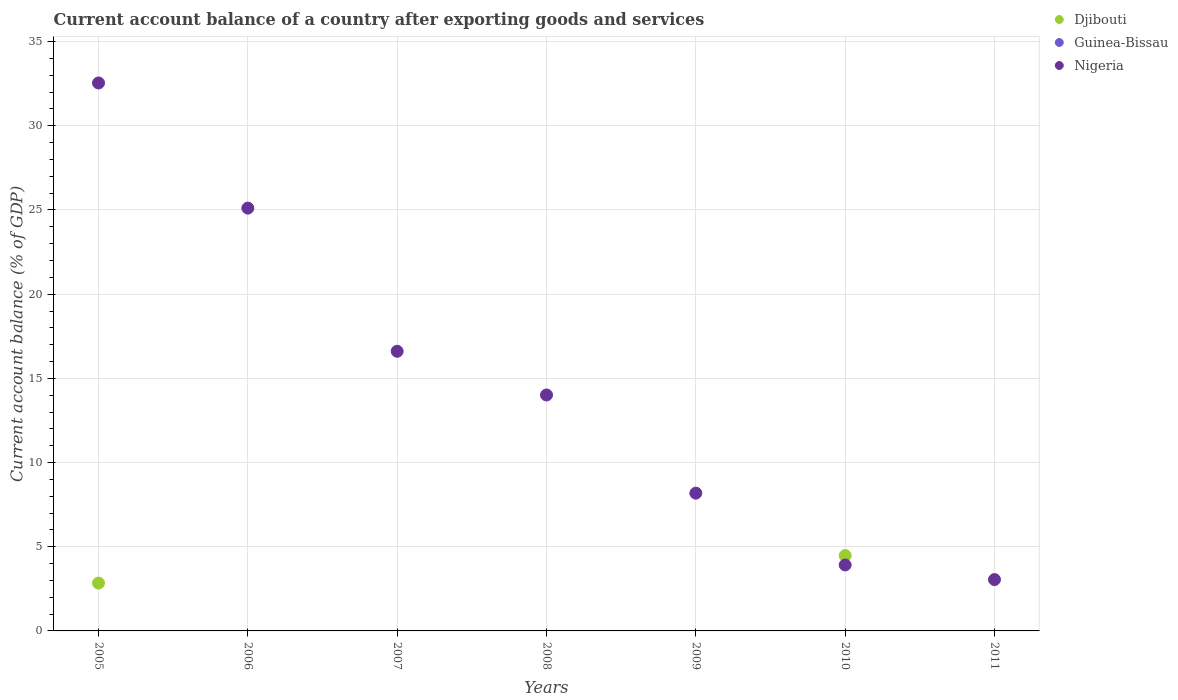Is the number of dotlines equal to the number of legend labels?
Offer a terse response. No. Across all years, what is the maximum account balance in Nigeria?
Keep it short and to the point. 32.54. Across all years, what is the minimum account balance in Nigeria?
Your response must be concise. 3.05. What is the total account balance in Nigeria in the graph?
Provide a short and direct response. 103.42. What is the difference between the account balance in Djibouti in 2005 and that in 2010?
Provide a short and direct response. -1.63. What is the difference between the account balance in Guinea-Bissau in 2007 and the account balance in Nigeria in 2010?
Give a very brief answer. -3.92. What is the average account balance in Djibouti per year?
Provide a succinct answer. 1.04. In how many years, is the account balance in Nigeria greater than 29 %?
Give a very brief answer. 1. What is the ratio of the account balance in Nigeria in 2005 to that in 2009?
Ensure brevity in your answer.  3.98. What is the difference between the highest and the second highest account balance in Nigeria?
Your answer should be compact. 7.43. What is the difference between the highest and the lowest account balance in Nigeria?
Your answer should be compact. 29.49. Is it the case that in every year, the sum of the account balance in Nigeria and account balance in Guinea-Bissau  is greater than the account balance in Djibouti?
Make the answer very short. No. How many dotlines are there?
Your response must be concise. 2. How many years are there in the graph?
Give a very brief answer. 7. Where does the legend appear in the graph?
Your answer should be very brief. Top right. How are the legend labels stacked?
Ensure brevity in your answer.  Vertical. What is the title of the graph?
Give a very brief answer. Current account balance of a country after exporting goods and services. Does "Egypt, Arab Rep." appear as one of the legend labels in the graph?
Provide a short and direct response. No. What is the label or title of the Y-axis?
Make the answer very short. Current account balance (% of GDP). What is the Current account balance (% of GDP) of Djibouti in 2005?
Your response must be concise. 2.84. What is the Current account balance (% of GDP) of Nigeria in 2005?
Give a very brief answer. 32.54. What is the Current account balance (% of GDP) in Djibouti in 2006?
Your answer should be very brief. 0. What is the Current account balance (% of GDP) of Nigeria in 2006?
Provide a short and direct response. 25.11. What is the Current account balance (% of GDP) in Nigeria in 2007?
Offer a very short reply. 16.61. What is the Current account balance (% of GDP) of Guinea-Bissau in 2008?
Make the answer very short. 0. What is the Current account balance (% of GDP) in Nigeria in 2008?
Provide a short and direct response. 14.01. What is the Current account balance (% of GDP) in Djibouti in 2009?
Your answer should be compact. 0. What is the Current account balance (% of GDP) in Nigeria in 2009?
Keep it short and to the point. 8.18. What is the Current account balance (% of GDP) in Djibouti in 2010?
Your answer should be very brief. 4.47. What is the Current account balance (% of GDP) of Nigeria in 2010?
Offer a very short reply. 3.92. What is the Current account balance (% of GDP) of Nigeria in 2011?
Make the answer very short. 3.05. Across all years, what is the maximum Current account balance (% of GDP) in Djibouti?
Your answer should be compact. 4.47. Across all years, what is the maximum Current account balance (% of GDP) in Nigeria?
Make the answer very short. 32.54. Across all years, what is the minimum Current account balance (% of GDP) in Nigeria?
Make the answer very short. 3.05. What is the total Current account balance (% of GDP) of Djibouti in the graph?
Make the answer very short. 7.31. What is the total Current account balance (% of GDP) in Nigeria in the graph?
Give a very brief answer. 103.42. What is the difference between the Current account balance (% of GDP) of Nigeria in 2005 and that in 2006?
Give a very brief answer. 7.43. What is the difference between the Current account balance (% of GDP) of Nigeria in 2005 and that in 2007?
Your answer should be compact. 15.94. What is the difference between the Current account balance (% of GDP) of Nigeria in 2005 and that in 2008?
Ensure brevity in your answer.  18.53. What is the difference between the Current account balance (% of GDP) of Nigeria in 2005 and that in 2009?
Offer a terse response. 24.36. What is the difference between the Current account balance (% of GDP) of Djibouti in 2005 and that in 2010?
Your answer should be compact. -1.63. What is the difference between the Current account balance (% of GDP) in Nigeria in 2005 and that in 2010?
Your answer should be very brief. 28.63. What is the difference between the Current account balance (% of GDP) of Nigeria in 2005 and that in 2011?
Provide a succinct answer. 29.49. What is the difference between the Current account balance (% of GDP) in Nigeria in 2006 and that in 2007?
Ensure brevity in your answer.  8.5. What is the difference between the Current account balance (% of GDP) of Nigeria in 2006 and that in 2008?
Your answer should be very brief. 11.1. What is the difference between the Current account balance (% of GDP) in Nigeria in 2006 and that in 2009?
Offer a terse response. 16.93. What is the difference between the Current account balance (% of GDP) in Nigeria in 2006 and that in 2010?
Provide a succinct answer. 21.19. What is the difference between the Current account balance (% of GDP) in Nigeria in 2006 and that in 2011?
Provide a short and direct response. 22.06. What is the difference between the Current account balance (% of GDP) of Nigeria in 2007 and that in 2008?
Ensure brevity in your answer.  2.6. What is the difference between the Current account balance (% of GDP) in Nigeria in 2007 and that in 2009?
Provide a short and direct response. 8.43. What is the difference between the Current account balance (% of GDP) of Nigeria in 2007 and that in 2010?
Make the answer very short. 12.69. What is the difference between the Current account balance (% of GDP) of Nigeria in 2007 and that in 2011?
Provide a short and direct response. 13.56. What is the difference between the Current account balance (% of GDP) in Nigeria in 2008 and that in 2009?
Ensure brevity in your answer.  5.83. What is the difference between the Current account balance (% of GDP) in Nigeria in 2008 and that in 2010?
Keep it short and to the point. 10.09. What is the difference between the Current account balance (% of GDP) in Nigeria in 2008 and that in 2011?
Ensure brevity in your answer.  10.96. What is the difference between the Current account balance (% of GDP) in Nigeria in 2009 and that in 2010?
Provide a short and direct response. 4.26. What is the difference between the Current account balance (% of GDP) of Nigeria in 2009 and that in 2011?
Ensure brevity in your answer.  5.13. What is the difference between the Current account balance (% of GDP) of Nigeria in 2010 and that in 2011?
Your answer should be compact. 0.87. What is the difference between the Current account balance (% of GDP) of Djibouti in 2005 and the Current account balance (% of GDP) of Nigeria in 2006?
Keep it short and to the point. -22.27. What is the difference between the Current account balance (% of GDP) of Djibouti in 2005 and the Current account balance (% of GDP) of Nigeria in 2007?
Give a very brief answer. -13.77. What is the difference between the Current account balance (% of GDP) in Djibouti in 2005 and the Current account balance (% of GDP) in Nigeria in 2008?
Offer a very short reply. -11.17. What is the difference between the Current account balance (% of GDP) of Djibouti in 2005 and the Current account balance (% of GDP) of Nigeria in 2009?
Give a very brief answer. -5.34. What is the difference between the Current account balance (% of GDP) in Djibouti in 2005 and the Current account balance (% of GDP) in Nigeria in 2010?
Provide a succinct answer. -1.08. What is the difference between the Current account balance (% of GDP) in Djibouti in 2005 and the Current account balance (% of GDP) in Nigeria in 2011?
Your answer should be compact. -0.21. What is the difference between the Current account balance (% of GDP) in Djibouti in 2010 and the Current account balance (% of GDP) in Nigeria in 2011?
Your answer should be compact. 1.42. What is the average Current account balance (% of GDP) of Djibouti per year?
Offer a very short reply. 1.04. What is the average Current account balance (% of GDP) of Guinea-Bissau per year?
Offer a very short reply. 0. What is the average Current account balance (% of GDP) of Nigeria per year?
Offer a very short reply. 14.77. In the year 2005, what is the difference between the Current account balance (% of GDP) of Djibouti and Current account balance (% of GDP) of Nigeria?
Your answer should be compact. -29.7. In the year 2010, what is the difference between the Current account balance (% of GDP) of Djibouti and Current account balance (% of GDP) of Nigeria?
Your answer should be compact. 0.56. What is the ratio of the Current account balance (% of GDP) of Nigeria in 2005 to that in 2006?
Your response must be concise. 1.3. What is the ratio of the Current account balance (% of GDP) of Nigeria in 2005 to that in 2007?
Keep it short and to the point. 1.96. What is the ratio of the Current account balance (% of GDP) in Nigeria in 2005 to that in 2008?
Your response must be concise. 2.32. What is the ratio of the Current account balance (% of GDP) in Nigeria in 2005 to that in 2009?
Provide a succinct answer. 3.98. What is the ratio of the Current account balance (% of GDP) in Djibouti in 2005 to that in 2010?
Your response must be concise. 0.64. What is the ratio of the Current account balance (% of GDP) in Nigeria in 2005 to that in 2010?
Offer a very short reply. 8.31. What is the ratio of the Current account balance (% of GDP) in Nigeria in 2005 to that in 2011?
Ensure brevity in your answer.  10.67. What is the ratio of the Current account balance (% of GDP) of Nigeria in 2006 to that in 2007?
Provide a short and direct response. 1.51. What is the ratio of the Current account balance (% of GDP) in Nigeria in 2006 to that in 2008?
Provide a short and direct response. 1.79. What is the ratio of the Current account balance (% of GDP) in Nigeria in 2006 to that in 2009?
Make the answer very short. 3.07. What is the ratio of the Current account balance (% of GDP) of Nigeria in 2006 to that in 2010?
Your response must be concise. 6.41. What is the ratio of the Current account balance (% of GDP) of Nigeria in 2006 to that in 2011?
Make the answer very short. 8.24. What is the ratio of the Current account balance (% of GDP) in Nigeria in 2007 to that in 2008?
Provide a succinct answer. 1.19. What is the ratio of the Current account balance (% of GDP) in Nigeria in 2007 to that in 2009?
Ensure brevity in your answer.  2.03. What is the ratio of the Current account balance (% of GDP) in Nigeria in 2007 to that in 2010?
Make the answer very short. 4.24. What is the ratio of the Current account balance (% of GDP) in Nigeria in 2007 to that in 2011?
Provide a succinct answer. 5.45. What is the ratio of the Current account balance (% of GDP) of Nigeria in 2008 to that in 2009?
Ensure brevity in your answer.  1.71. What is the ratio of the Current account balance (% of GDP) of Nigeria in 2008 to that in 2010?
Ensure brevity in your answer.  3.58. What is the ratio of the Current account balance (% of GDP) in Nigeria in 2008 to that in 2011?
Give a very brief answer. 4.6. What is the ratio of the Current account balance (% of GDP) in Nigeria in 2009 to that in 2010?
Offer a very short reply. 2.09. What is the ratio of the Current account balance (% of GDP) of Nigeria in 2009 to that in 2011?
Offer a terse response. 2.68. What is the ratio of the Current account balance (% of GDP) of Nigeria in 2010 to that in 2011?
Offer a very short reply. 1.28. What is the difference between the highest and the second highest Current account balance (% of GDP) in Nigeria?
Make the answer very short. 7.43. What is the difference between the highest and the lowest Current account balance (% of GDP) of Djibouti?
Your response must be concise. 4.47. What is the difference between the highest and the lowest Current account balance (% of GDP) in Nigeria?
Make the answer very short. 29.49. 